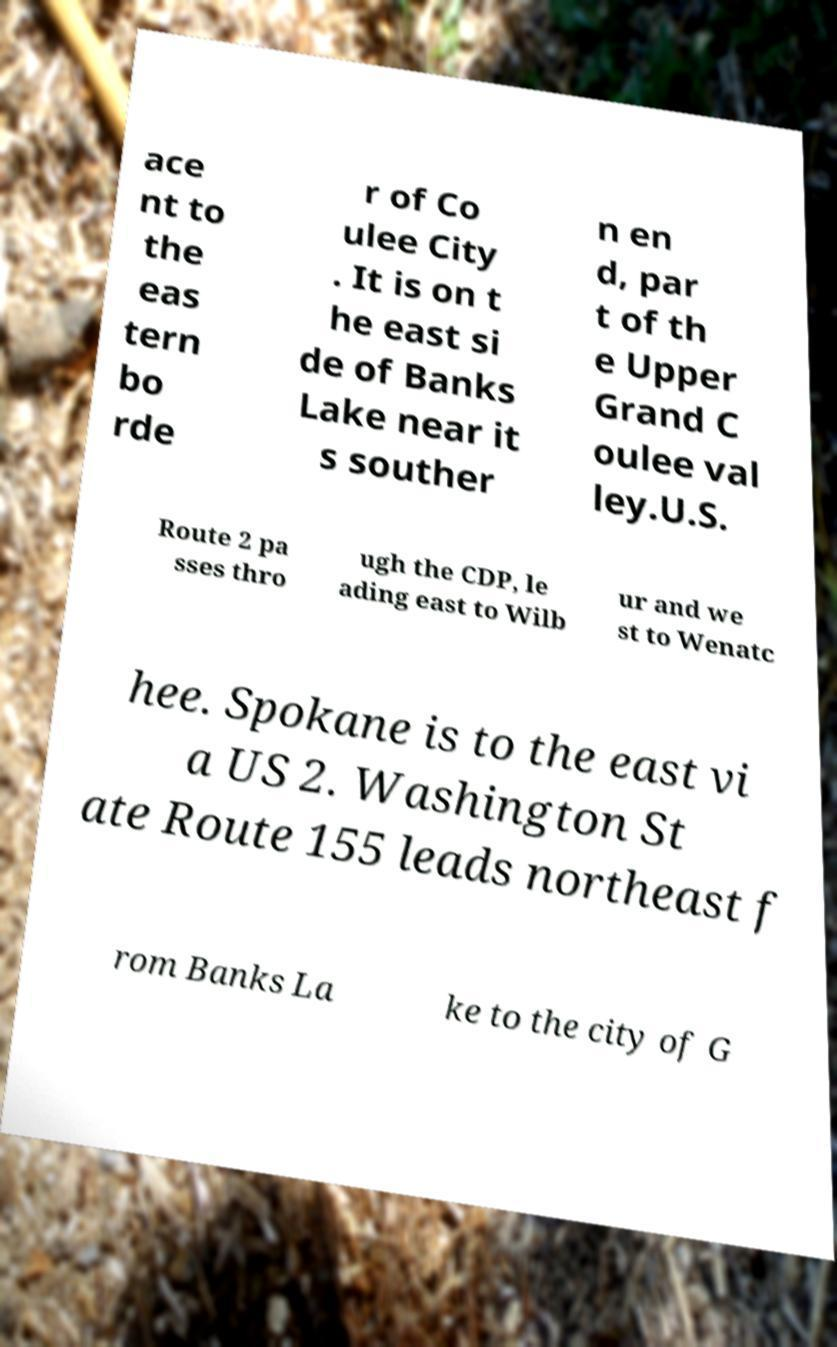I need the written content from this picture converted into text. Can you do that? ace nt to the eas tern bo rde r of Co ulee City . It is on t he east si de of Banks Lake near it s souther n en d, par t of th e Upper Grand C oulee val ley.U.S. Route 2 pa sses thro ugh the CDP, le ading east to Wilb ur and we st to Wenatc hee. Spokane is to the east vi a US 2. Washington St ate Route 155 leads northeast f rom Banks La ke to the city of G 